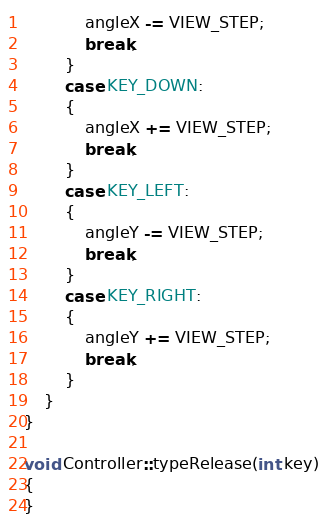<code> <loc_0><loc_0><loc_500><loc_500><_C++_>			angleX -= VIEW_STEP;
			break;
		}
		case KEY_DOWN:
		{
			angleX += VIEW_STEP;
			break;
		}
		case KEY_LEFT:
		{
			angleY -= VIEW_STEP;
			break;
		}
		case KEY_RIGHT:
		{
			angleY += VIEW_STEP;
			break;
		}
	}
}

void Controller::typeRelease(int key)
{
}

</code> 